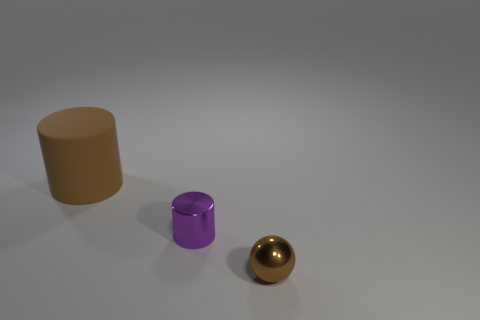Add 1 metallic balls. How many objects exist? 4 Subtract all spheres. How many objects are left? 2 Subtract all purple spheres. Subtract all cyan cylinders. How many spheres are left? 1 Subtract all tiny purple cylinders. Subtract all big brown matte cylinders. How many objects are left? 1 Add 2 brown objects. How many brown objects are left? 4 Add 1 tiny brown things. How many tiny brown things exist? 2 Subtract 0 blue cylinders. How many objects are left? 3 